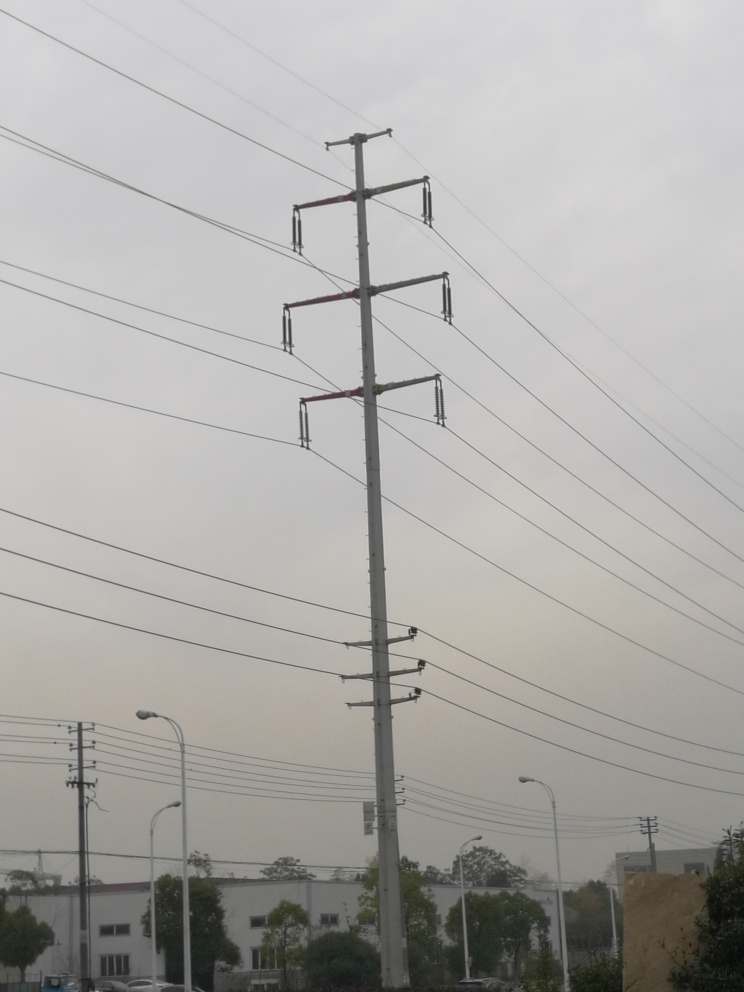Does this image indicate any environmental concerns? While the image itself does not provide direct evidence of environmental issues, the presence of haze could suggest air pollution. Additionally, power transmission infrastructure, like the tower seen here, often prompts discussions about visual impact and land use. 